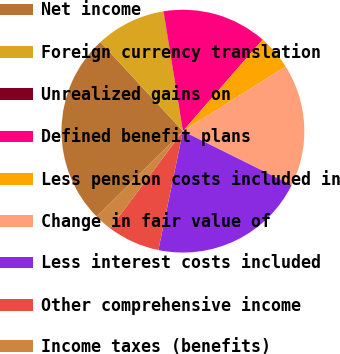<chart> <loc_0><loc_0><loc_500><loc_500><pie_chart><fcel>Net income<fcel>Foreign currency translation<fcel>Unrealized gains on<fcel>Defined benefit plans<fcel>Less pension costs included in<fcel>Change in fair value of<fcel>Less interest costs included<fcel>Other comprehensive income<fcel>Income taxes (benefits)<nl><fcel>25.54%<fcel>9.31%<fcel>0.03%<fcel>13.95%<fcel>4.67%<fcel>16.27%<fcel>20.9%<fcel>6.99%<fcel>2.35%<nl></chart> 